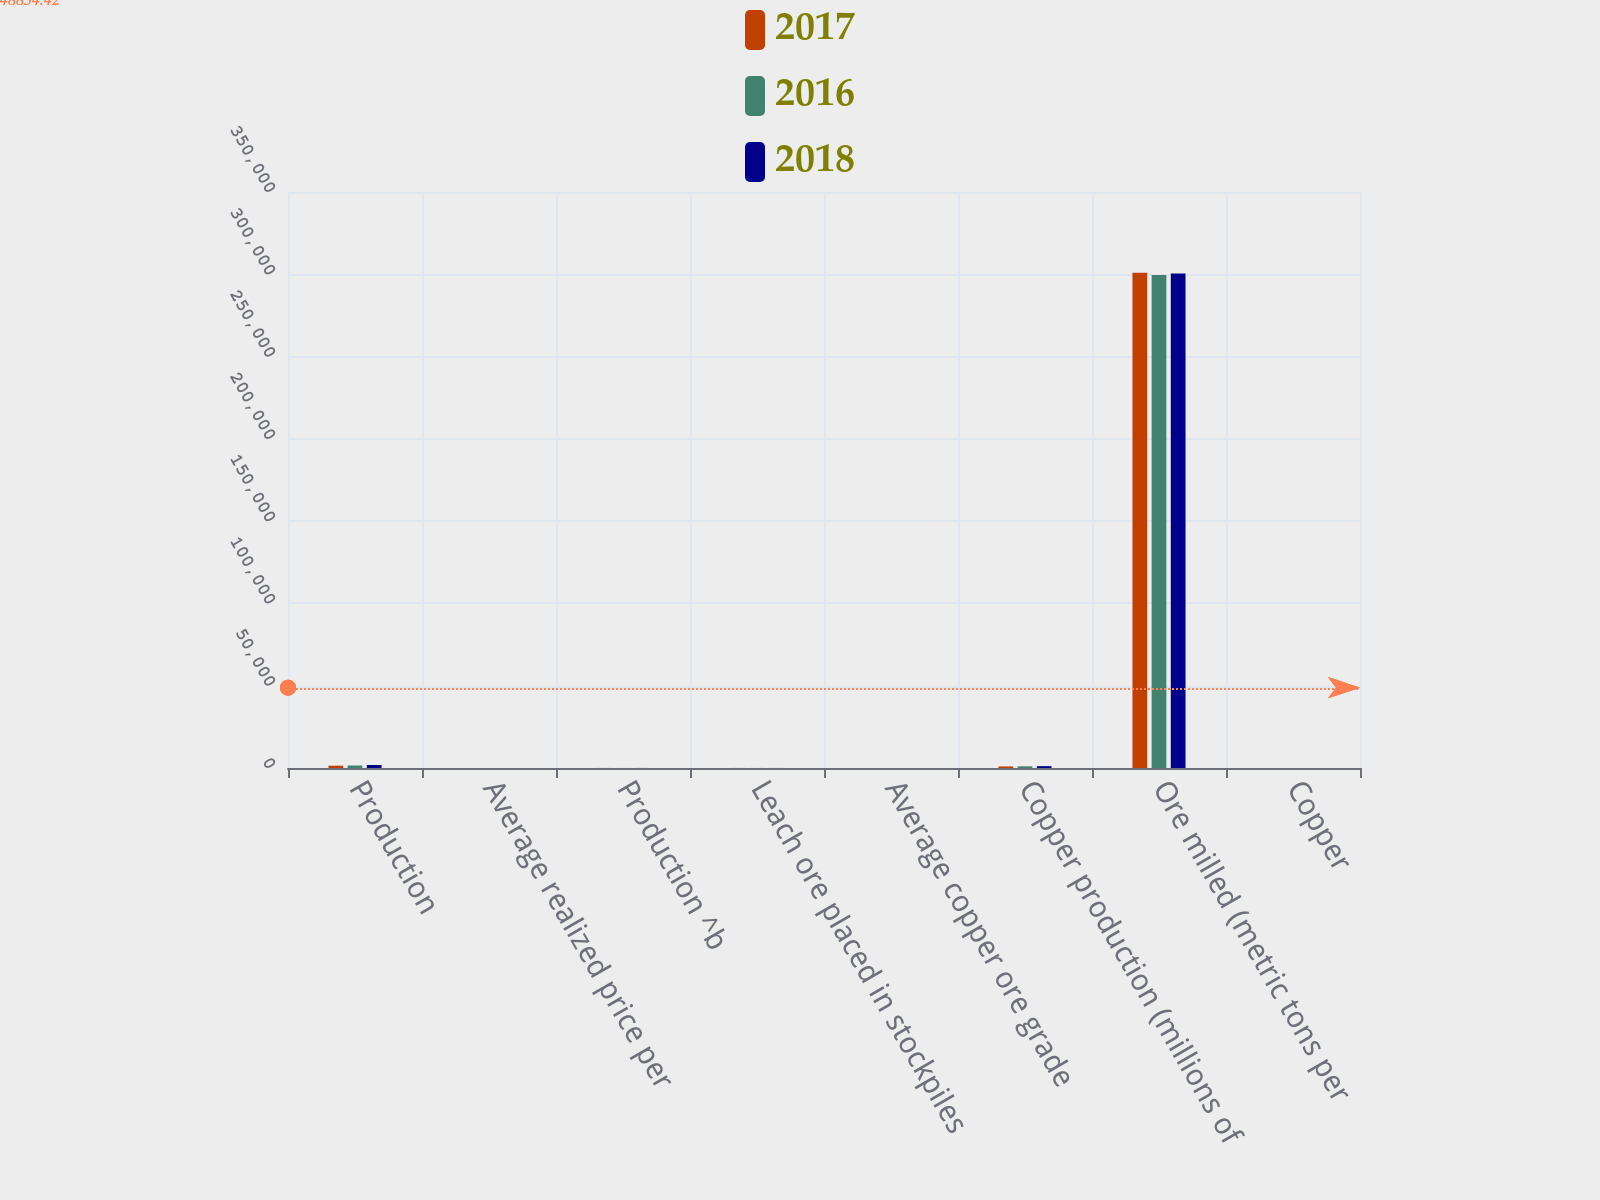<chart> <loc_0><loc_0><loc_500><loc_500><stacked_bar_chart><ecel><fcel>Production<fcel>Average realized price per<fcel>Production ^b<fcel>Leach ore placed in stockpiles<fcel>Average copper ore grade<fcel>Copper production (millions of<fcel>Ore milled (metric tons per<fcel>Copper<nl><fcel>2017<fcel>1404<fcel>2.96<fcel>32<fcel>33<fcel>0.24<fcel>951<fcel>301000<fcel>0.35<nl><fcel>2016<fcel>1518<fcel>2.85<fcel>33<fcel>33<fcel>0.28<fcel>1016<fcel>299500<fcel>0.39<nl><fcel>2018<fcel>1831<fcel>2.24<fcel>33<fcel>33<fcel>0.31<fcel>1120<fcel>300500<fcel>0.47<nl></chart> 